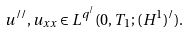Convert formula to latex. <formula><loc_0><loc_0><loc_500><loc_500>u ^ { / / } , u _ { x x } \in L ^ { q ^ { / } } ( 0 , T _ { 1 } ; ( H ^ { 1 } ) ^ { / } ) .</formula> 